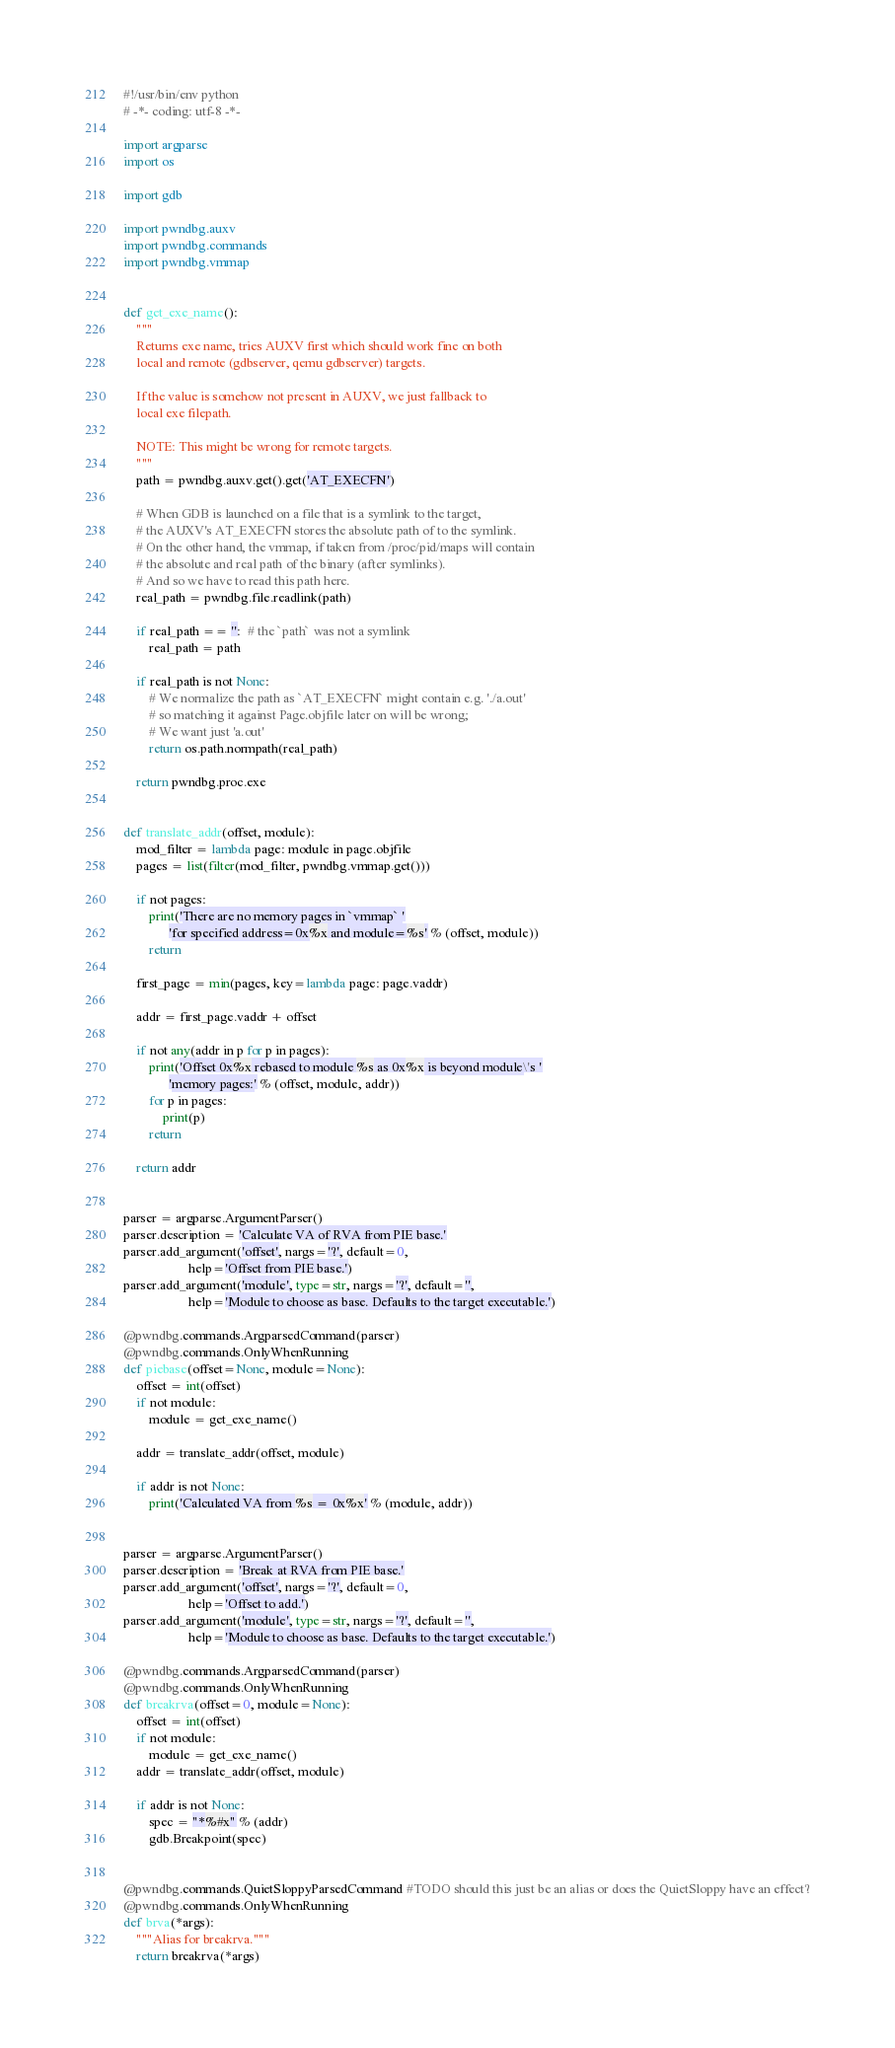Convert code to text. <code><loc_0><loc_0><loc_500><loc_500><_Python_>#!/usr/bin/env python
# -*- coding: utf-8 -*-

import argparse
import os

import gdb

import pwndbg.auxv
import pwndbg.commands
import pwndbg.vmmap


def get_exe_name():
    """
    Returns exe name, tries AUXV first which should work fine on both
    local and remote (gdbserver, qemu gdbserver) targets.

    If the value is somehow not present in AUXV, we just fallback to
    local exe filepath.

    NOTE: This might be wrong for remote targets.
    """
    path = pwndbg.auxv.get().get('AT_EXECFN')

    # When GDB is launched on a file that is a symlink to the target,
    # the AUXV's AT_EXECFN stores the absolute path of to the symlink.
    # On the other hand, the vmmap, if taken from /proc/pid/maps will contain
    # the absolute and real path of the binary (after symlinks).
    # And so we have to read this path here.
    real_path = pwndbg.file.readlink(path)

    if real_path == '':  # the `path` was not a symlink
        real_path = path

    if real_path is not None:
        # We normalize the path as `AT_EXECFN` might contain e.g. './a.out'
        # so matching it against Page.objfile later on will be wrong;
        # We want just 'a.out'
        return os.path.normpath(real_path)

    return pwndbg.proc.exe


def translate_addr(offset, module):
    mod_filter = lambda page: module in page.objfile
    pages = list(filter(mod_filter, pwndbg.vmmap.get()))

    if not pages:
        print('There are no memory pages in `vmmap` '
              'for specified address=0x%x and module=%s' % (offset, module))
        return

    first_page = min(pages, key=lambda page: page.vaddr)

    addr = first_page.vaddr + offset

    if not any(addr in p for p in pages):
        print('Offset 0x%x rebased to module %s as 0x%x is beyond module\'s '
              'memory pages:' % (offset, module, addr))
        for p in pages:
            print(p)
        return

    return addr


parser = argparse.ArgumentParser()
parser.description = 'Calculate VA of RVA from PIE base.'
parser.add_argument('offset', nargs='?', default=0,
                    help='Offset from PIE base.')
parser.add_argument('module', type=str, nargs='?', default='',
                    help='Module to choose as base. Defaults to the target executable.')

@pwndbg.commands.ArgparsedCommand(parser)
@pwndbg.commands.OnlyWhenRunning
def piebase(offset=None, module=None):
    offset = int(offset)
    if not module:
        module = get_exe_name()

    addr = translate_addr(offset, module)

    if addr is not None:
        print('Calculated VA from %s = 0x%x' % (module, addr))


parser = argparse.ArgumentParser()
parser.description = 'Break at RVA from PIE base.'
parser.add_argument('offset', nargs='?', default=0,
                    help='Offset to add.')
parser.add_argument('module', type=str, nargs='?', default='',
                    help='Module to choose as base. Defaults to the target executable.')

@pwndbg.commands.ArgparsedCommand(parser)
@pwndbg.commands.OnlyWhenRunning
def breakrva(offset=0, module=None):
    offset = int(offset)
    if not module:
        module = get_exe_name()
    addr = translate_addr(offset, module)

    if addr is not None:
        spec = "*%#x" % (addr)
        gdb.Breakpoint(spec)


@pwndbg.commands.QuietSloppyParsedCommand #TODO should this just be an alias or does the QuietSloppy have an effect?
@pwndbg.commands.OnlyWhenRunning
def brva(*args):
    """Alias for breakrva."""
    return breakrva(*args)
</code> 